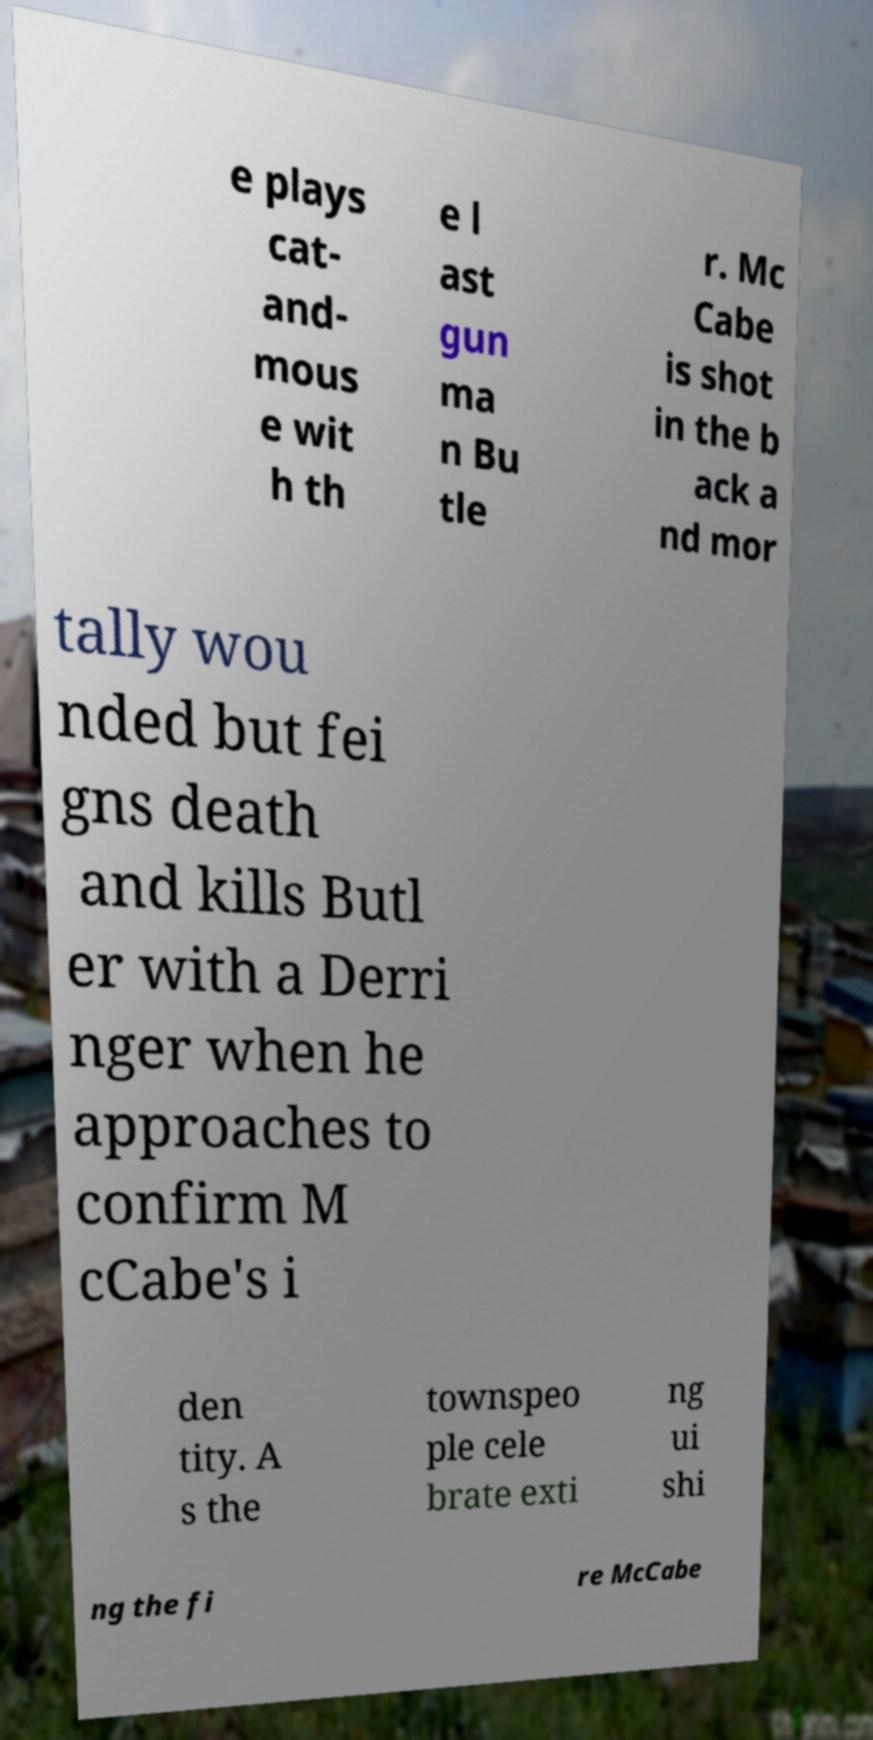Can you accurately transcribe the text from the provided image for me? e plays cat- and- mous e wit h th e l ast gun ma n Bu tle r. Mc Cabe is shot in the b ack a nd mor tally wou nded but fei gns death and kills Butl er with a Derri nger when he approaches to confirm M cCabe's i den tity. A s the townspeo ple cele brate exti ng ui shi ng the fi re McCabe 